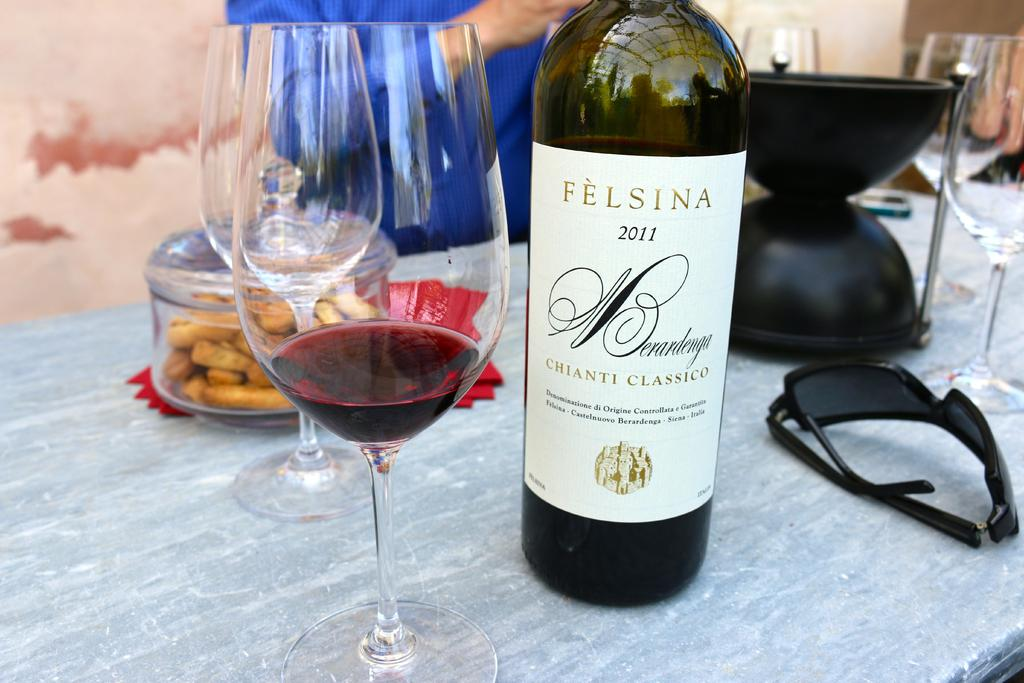<image>
Relay a brief, clear account of the picture shown. A bottle of Felsina wine from 2011 is on a table next to a glass. 